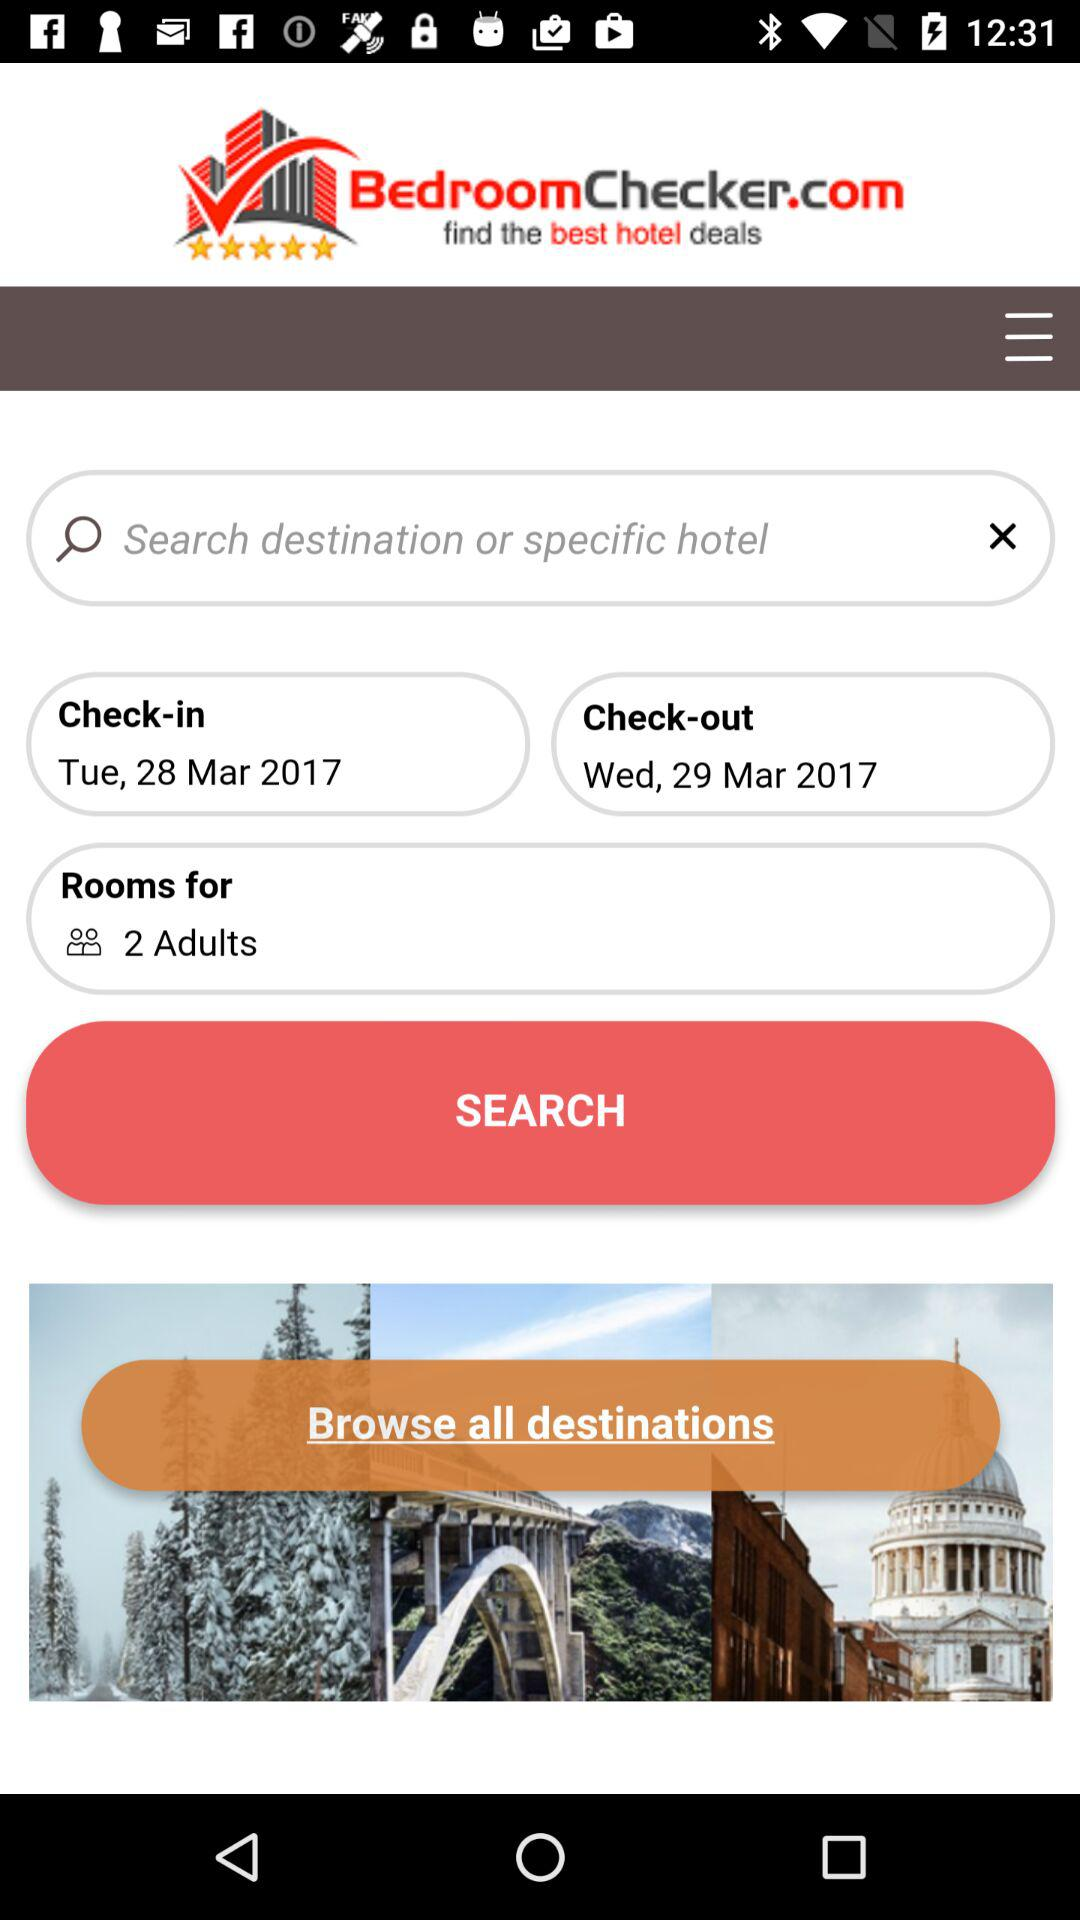What is the application name? The application name is "BedroomChecker.com". 